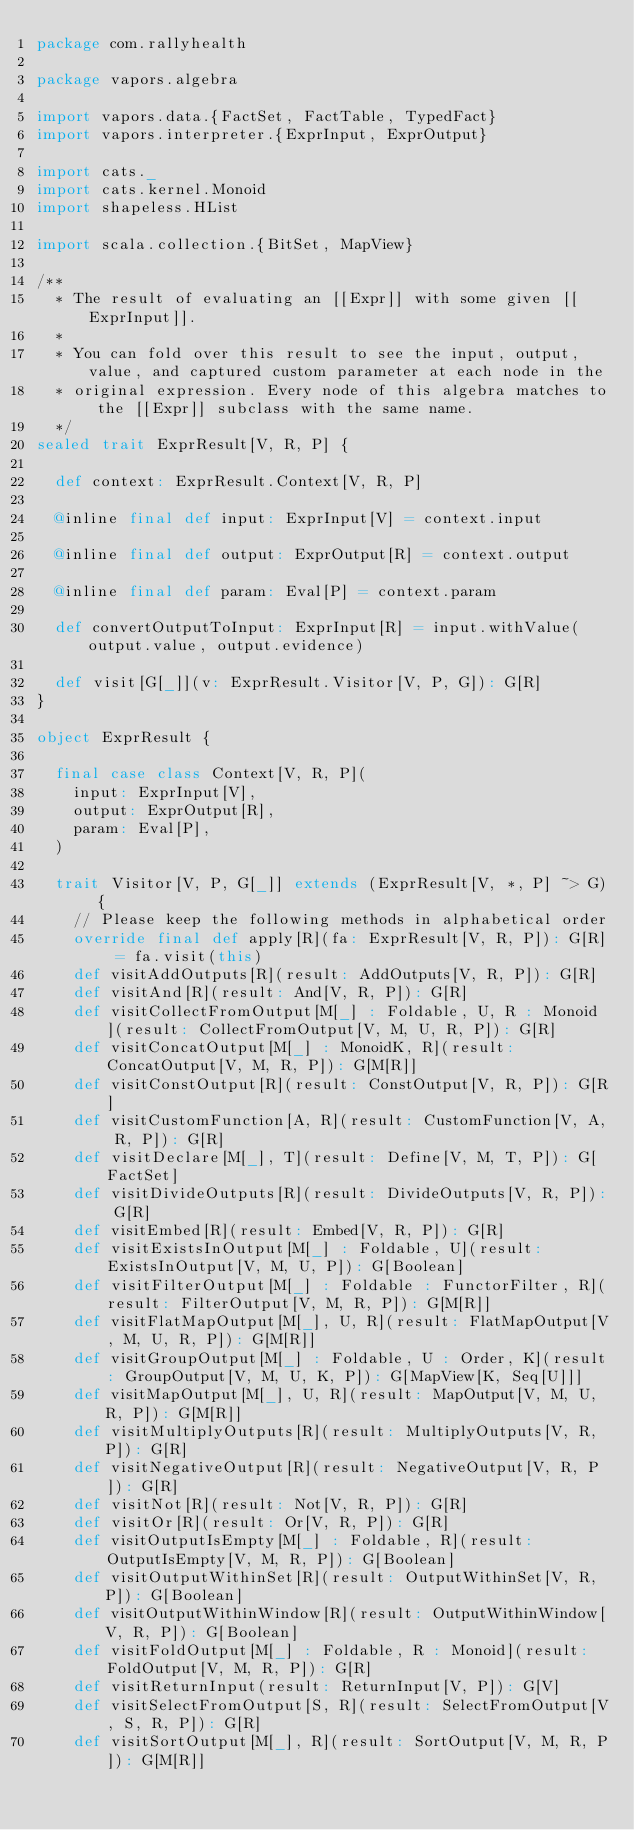<code> <loc_0><loc_0><loc_500><loc_500><_Scala_>package com.rallyhealth

package vapors.algebra

import vapors.data.{FactSet, FactTable, TypedFact}
import vapors.interpreter.{ExprInput, ExprOutput}

import cats._
import cats.kernel.Monoid
import shapeless.HList

import scala.collection.{BitSet, MapView}

/**
  * The result of evaluating an [[Expr]] with some given [[ExprInput]].
  *
  * You can fold over this result to see the input, output, value, and captured custom parameter at each node in the
  * original expression. Every node of this algebra matches to the [[Expr]] subclass with the same name.
  */
sealed trait ExprResult[V, R, P] {

  def context: ExprResult.Context[V, R, P]

  @inline final def input: ExprInput[V] = context.input

  @inline final def output: ExprOutput[R] = context.output

  @inline final def param: Eval[P] = context.param

  def convertOutputToInput: ExprInput[R] = input.withValue(output.value, output.evidence)

  def visit[G[_]](v: ExprResult.Visitor[V, P, G]): G[R]
}

object ExprResult {

  final case class Context[V, R, P](
    input: ExprInput[V],
    output: ExprOutput[R],
    param: Eval[P],
  )

  trait Visitor[V, P, G[_]] extends (ExprResult[V, *, P] ~> G) {
    // Please keep the following methods in alphabetical order
    override final def apply[R](fa: ExprResult[V, R, P]): G[R] = fa.visit(this)
    def visitAddOutputs[R](result: AddOutputs[V, R, P]): G[R]
    def visitAnd[R](result: And[V, R, P]): G[R]
    def visitCollectFromOutput[M[_] : Foldable, U, R : Monoid](result: CollectFromOutput[V, M, U, R, P]): G[R]
    def visitConcatOutput[M[_] : MonoidK, R](result: ConcatOutput[V, M, R, P]): G[M[R]]
    def visitConstOutput[R](result: ConstOutput[V, R, P]): G[R]
    def visitCustomFunction[A, R](result: CustomFunction[V, A, R, P]): G[R]
    def visitDeclare[M[_], T](result: Define[V, M, T, P]): G[FactSet]
    def visitDivideOutputs[R](result: DivideOutputs[V, R, P]): G[R]
    def visitEmbed[R](result: Embed[V, R, P]): G[R]
    def visitExistsInOutput[M[_] : Foldable, U](result: ExistsInOutput[V, M, U, P]): G[Boolean]
    def visitFilterOutput[M[_] : Foldable : FunctorFilter, R](result: FilterOutput[V, M, R, P]): G[M[R]]
    def visitFlatMapOutput[M[_], U, R](result: FlatMapOutput[V, M, U, R, P]): G[M[R]]
    def visitGroupOutput[M[_] : Foldable, U : Order, K](result: GroupOutput[V, M, U, K, P]): G[MapView[K, Seq[U]]]
    def visitMapOutput[M[_], U, R](result: MapOutput[V, M, U, R, P]): G[M[R]]
    def visitMultiplyOutputs[R](result: MultiplyOutputs[V, R, P]): G[R]
    def visitNegativeOutput[R](result: NegativeOutput[V, R, P]): G[R]
    def visitNot[R](result: Not[V, R, P]): G[R]
    def visitOr[R](result: Or[V, R, P]): G[R]
    def visitOutputIsEmpty[M[_] : Foldable, R](result: OutputIsEmpty[V, M, R, P]): G[Boolean]
    def visitOutputWithinSet[R](result: OutputWithinSet[V, R, P]): G[Boolean]
    def visitOutputWithinWindow[R](result: OutputWithinWindow[V, R, P]): G[Boolean]
    def visitFoldOutput[M[_] : Foldable, R : Monoid](result: FoldOutput[V, M, R, P]): G[R]
    def visitReturnInput(result: ReturnInput[V, P]): G[V]
    def visitSelectFromOutput[S, R](result: SelectFromOutput[V, S, R, P]): G[R]
    def visitSortOutput[M[_], R](result: SortOutput[V, M, R, P]): G[M[R]]</code> 